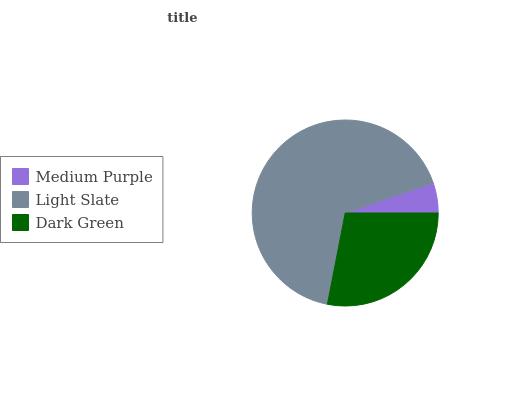Is Medium Purple the minimum?
Answer yes or no. Yes. Is Light Slate the maximum?
Answer yes or no. Yes. Is Dark Green the minimum?
Answer yes or no. No. Is Dark Green the maximum?
Answer yes or no. No. Is Light Slate greater than Dark Green?
Answer yes or no. Yes. Is Dark Green less than Light Slate?
Answer yes or no. Yes. Is Dark Green greater than Light Slate?
Answer yes or no. No. Is Light Slate less than Dark Green?
Answer yes or no. No. Is Dark Green the high median?
Answer yes or no. Yes. Is Dark Green the low median?
Answer yes or no. Yes. Is Medium Purple the high median?
Answer yes or no. No. Is Light Slate the low median?
Answer yes or no. No. 